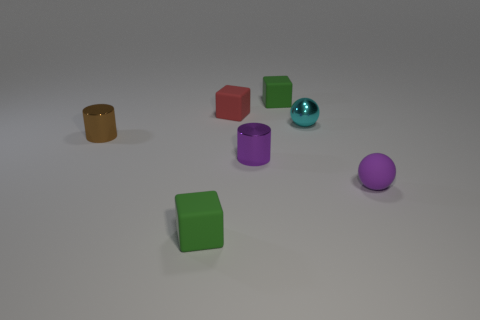Are there any other things that are made of the same material as the small brown cylinder?
Your response must be concise. Yes. Is the shape of the green thing that is in front of the purple metal object the same as the small green object behind the cyan thing?
Ensure brevity in your answer.  Yes. How many objects are there?
Keep it short and to the point. 7. There is a brown thing that is made of the same material as the cyan object; what is its shape?
Offer a terse response. Cylinder. Is there any other thing that is the same color as the small metallic ball?
Provide a short and direct response. No. Is the color of the matte ball the same as the matte cube on the left side of the red matte thing?
Offer a very short reply. No. Is the number of green rubber blocks that are on the left side of the brown metallic object less than the number of red blocks?
Keep it short and to the point. Yes. What material is the tiny purple object that is to the left of the cyan object?
Provide a short and direct response. Metal. What number of other objects are there of the same size as the brown cylinder?
Give a very brief answer. 6. Is the size of the purple rubber thing the same as the shiny object in front of the brown shiny thing?
Give a very brief answer. Yes. 